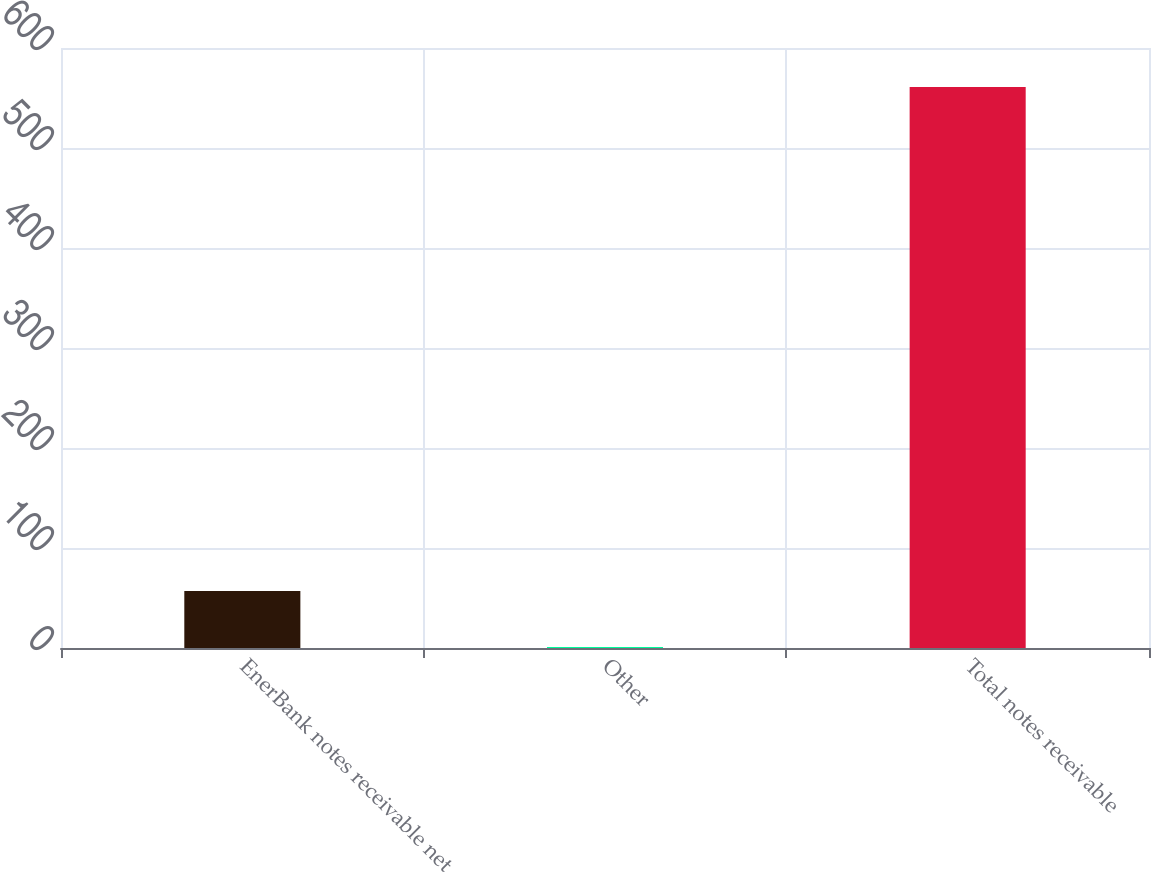Convert chart to OTSL. <chart><loc_0><loc_0><loc_500><loc_500><bar_chart><fcel>EnerBank notes receivable net<fcel>Other<fcel>Total notes receivable<nl><fcel>57<fcel>1<fcel>561<nl></chart> 